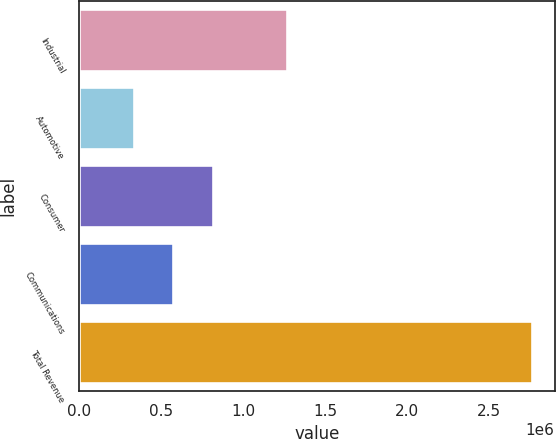Convert chart to OTSL. <chart><loc_0><loc_0><loc_500><loc_500><bar_chart><fcel>Industrial<fcel>Automotive<fcel>Consumer<fcel>Communications<fcel>Total Revenue<nl><fcel>1.26774e+06<fcel>333644<fcel>819216<fcel>576430<fcel>2.7615e+06<nl></chart> 